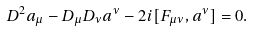Convert formula to latex. <formula><loc_0><loc_0><loc_500><loc_500>D ^ { 2 } a _ { \mu } - D _ { \mu } D _ { \nu } a ^ { \nu } - 2 i [ F _ { \mu \nu } , a ^ { \nu } ] = 0 .</formula> 